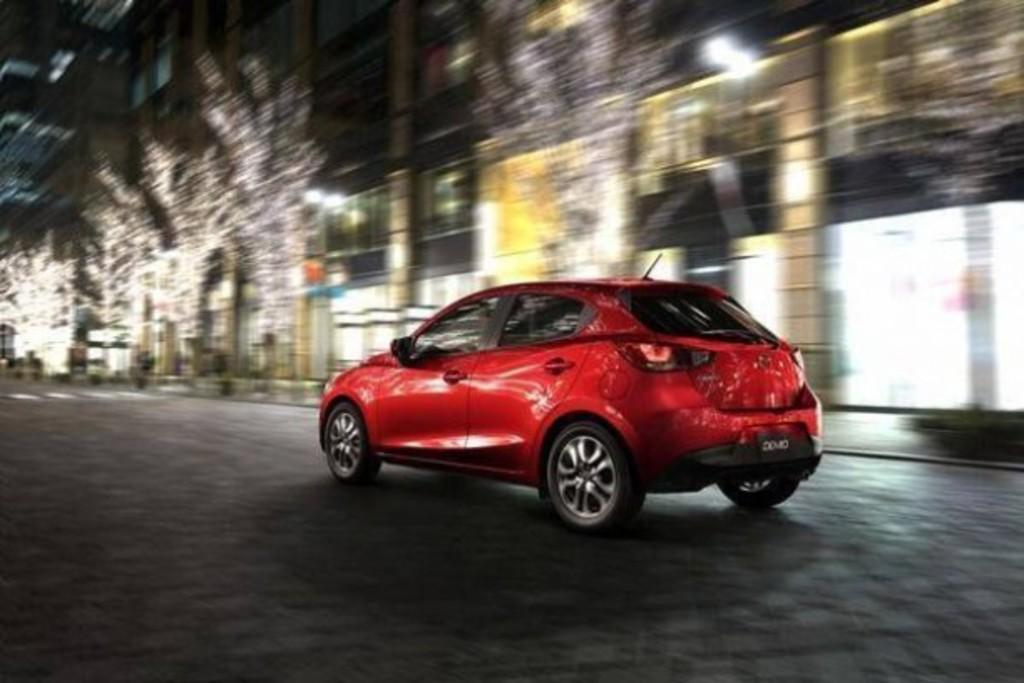What color is the car in the image? The car in the image is red. Where is the car located in the image? The car is on the road in the image. What can be seen in the background of the image? There are buildings and blurred trees visible in the background of the image. How many icicles are hanging from the car in the image? There are no icicles present in the image; it is a car on the road with no visible icicles. What type of loss is depicted in the image? There is no loss depicted in the image; it is a car on the road with no indication of any loss. 